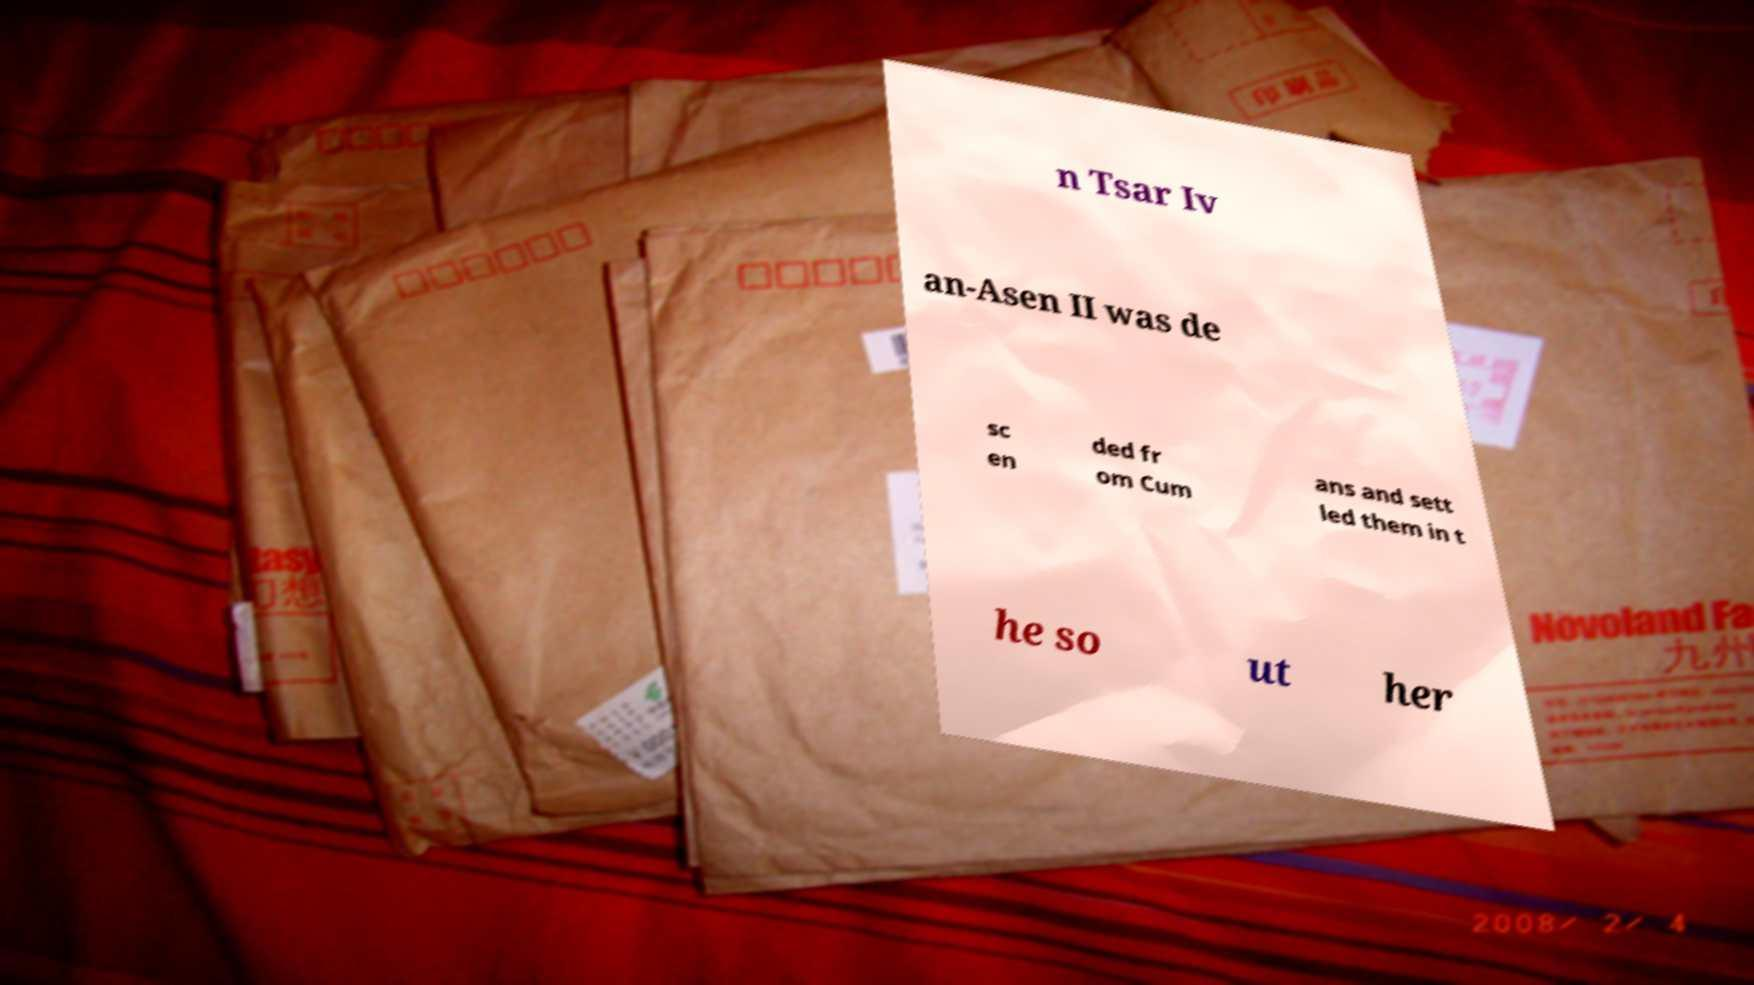Can you accurately transcribe the text from the provided image for me? n Tsar Iv an-Asen II was de sc en ded fr om Cum ans and sett led them in t he so ut her 